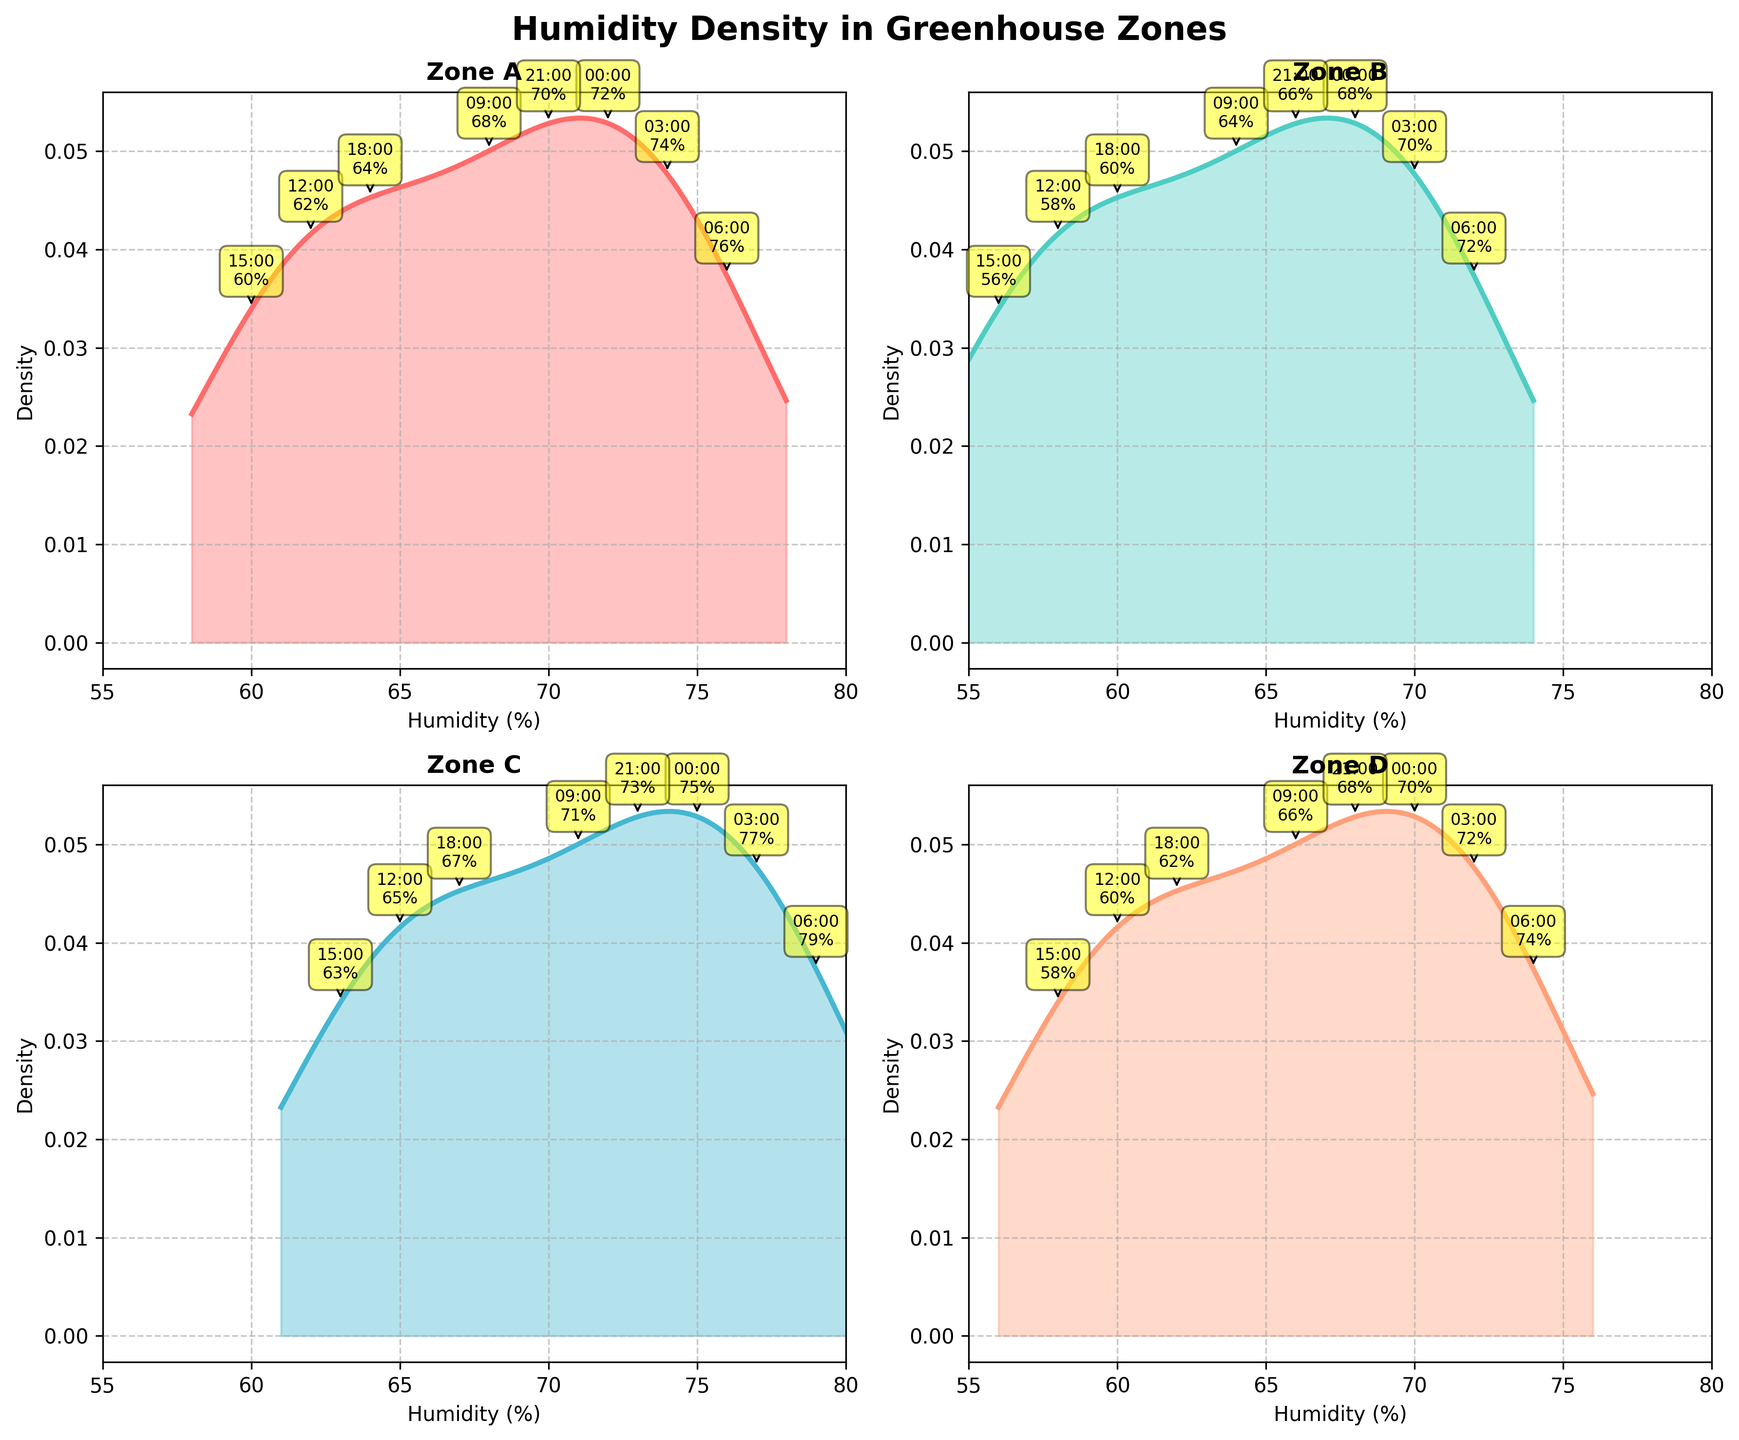How are the humidity levels distributed in Zone A? To determine the distribution, examine the density plot for Zone A. The plot shows the likelihood of humidity levels occurring within varying ranges. The peak indicates where most humidity readings cluster. Observe where the density is highest and note the spread.
Answer: The highest density is around 70% to 76% Which zone has the highest peak density in humidity? Compare the peak heights of density plots across all zones. The zone with the tallest peak indicates the highest concentration of humidity around a specific value.
Answer: Zone C What time has the lowest humidity in Zone B? Refer to the annotations next to the data points on the Zone B subplot. Identify the annotation with the lowest humidity value.
Answer: 15:00 (56%) Is there a time when all zones have roughly the same humidity? Cross-reference time labels on the subplots. Note occasions when humidity values across all zones are close to one another.
Answer: 21:00 What is the range of humidity values observed in Zone D? Identify the minimum and maximum humidity values on the x-axis for Zone D.
Answer: 58% to 72% Which two zones have the most similar density plots? Visually compare the shape and peak of the density plots for all zones. Look for those which have overlapping or closely aligned distributions.
Answer: Zone A and Zone D How does Zone A's humidity distribution compare to Zone B's? Analyze both density plots side by side. Note differences in peak height, spread, and central tendency.
Answer: Zone A generally has higher density around the central values than Zone B What is the highest humidity value reached in Zone C? Examine the annotations and range on the density plot for Zone C to find the maximum humidity value recorded.
Answer: 79% How do morning (06:00) humidity levels compare between all zones? Find the 06:00 humidity values annotated on each subplot then compare these values for all zones.
Answer: Zone A: 76%, Zone B: 72%, Zone C: 79%, Zone D: 74% Are there any notable patterns in the humidity levels throughout the day in any zone? Check for trends or patterns within individual density plots. Look for consistent peaks or dips at specific times of the day.
Answer: Zone C and Zone D have higher evening and lower afternoon humidity 